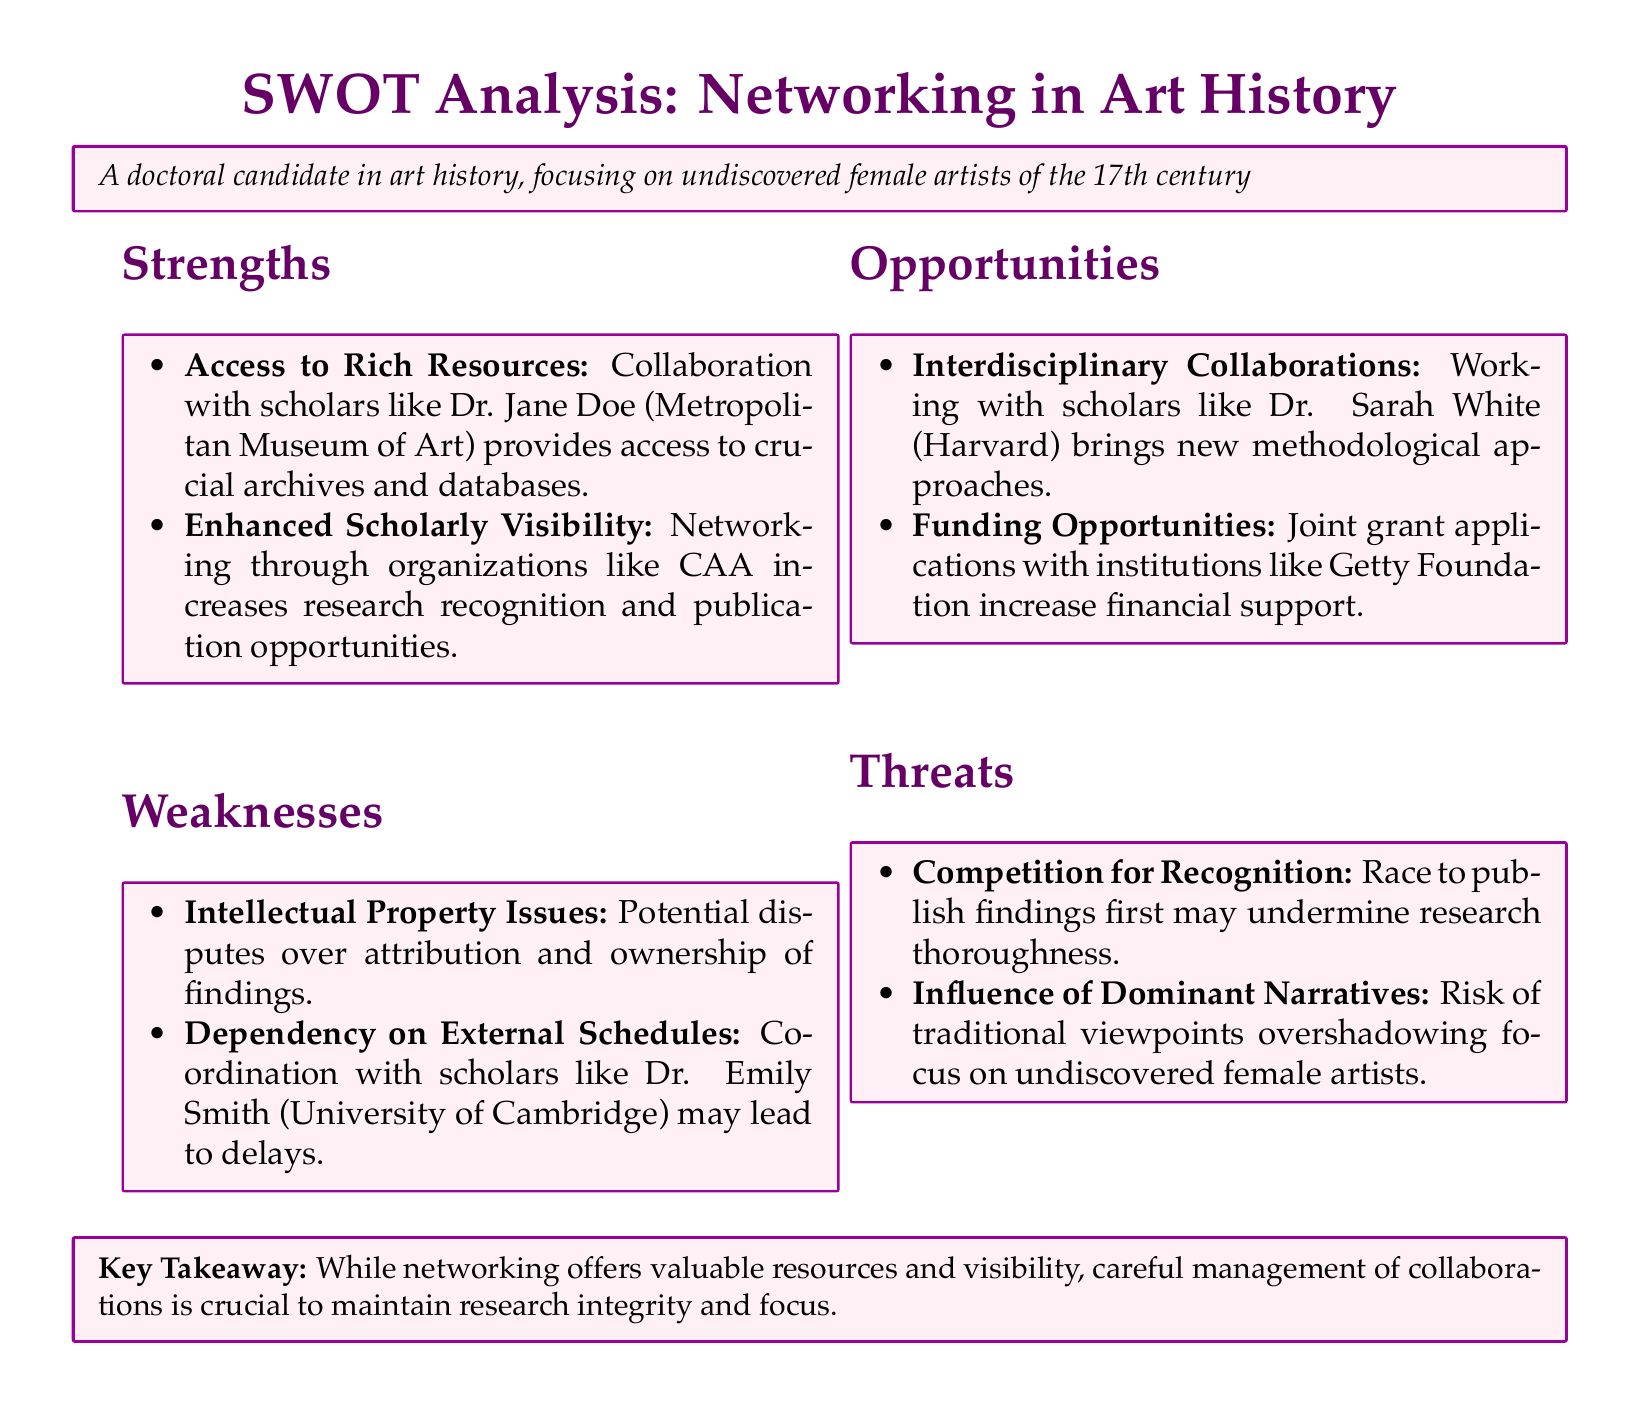what is a strength of networking in art history? Access to Rich Resources is listed as a strength in the document, highlighting the benefits of collaboration with prominent scholars.
Answer: Access to Rich Resources who is a potential collaborator mentioned in the weaknesses section? Dr. Emily Smith is named in the weaknesses section, indicating a potential dependency on her schedule.
Answer: Dr. Emily Smith what funding source is mentioned as an opportunity for collaboration? The Getty Foundation is identified as a source for joint grant applications in the opportunities section.
Answer: Getty Foundation what threat involves traditional viewpoints? The influence of Dominant Narratives is noted as a threat, emphasizing a risk to the focus on undiscovered female artists.
Answer: Dominant Narratives how many strengths are listed in the document? There are two strengths identified in the SWOT analysis concerning networking in art history.
Answer: two 